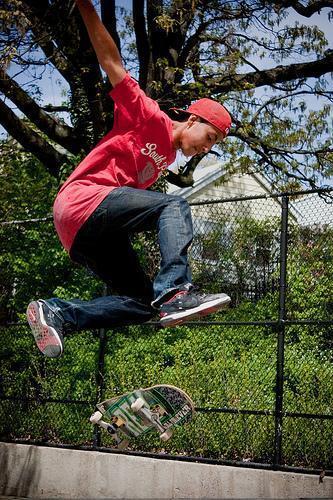How many houses in the photo?
Give a very brief answer. 1. 